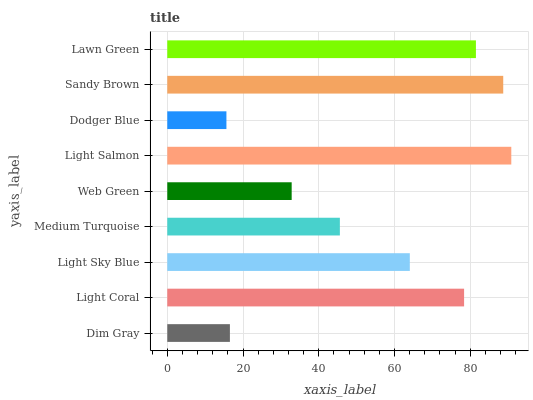Is Dodger Blue the minimum?
Answer yes or no. Yes. Is Light Salmon the maximum?
Answer yes or no. Yes. Is Light Coral the minimum?
Answer yes or no. No. Is Light Coral the maximum?
Answer yes or no. No. Is Light Coral greater than Dim Gray?
Answer yes or no. Yes. Is Dim Gray less than Light Coral?
Answer yes or no. Yes. Is Dim Gray greater than Light Coral?
Answer yes or no. No. Is Light Coral less than Dim Gray?
Answer yes or no. No. Is Light Sky Blue the high median?
Answer yes or no. Yes. Is Light Sky Blue the low median?
Answer yes or no. Yes. Is Dodger Blue the high median?
Answer yes or no. No. Is Dim Gray the low median?
Answer yes or no. No. 